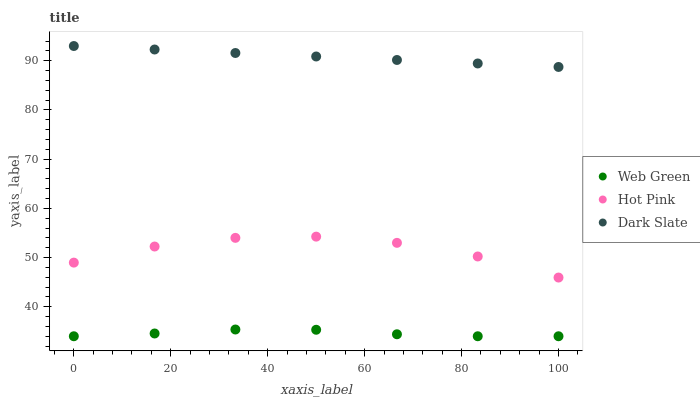Does Web Green have the minimum area under the curve?
Answer yes or no. Yes. Does Dark Slate have the maximum area under the curve?
Answer yes or no. Yes. Does Hot Pink have the minimum area under the curve?
Answer yes or no. No. Does Hot Pink have the maximum area under the curve?
Answer yes or no. No. Is Dark Slate the smoothest?
Answer yes or no. Yes. Is Hot Pink the roughest?
Answer yes or no. Yes. Is Web Green the smoothest?
Answer yes or no. No. Is Web Green the roughest?
Answer yes or no. No. Does Web Green have the lowest value?
Answer yes or no. Yes. Does Hot Pink have the lowest value?
Answer yes or no. No. Does Dark Slate have the highest value?
Answer yes or no. Yes. Does Hot Pink have the highest value?
Answer yes or no. No. Is Web Green less than Hot Pink?
Answer yes or no. Yes. Is Hot Pink greater than Web Green?
Answer yes or no. Yes. Does Web Green intersect Hot Pink?
Answer yes or no. No. 